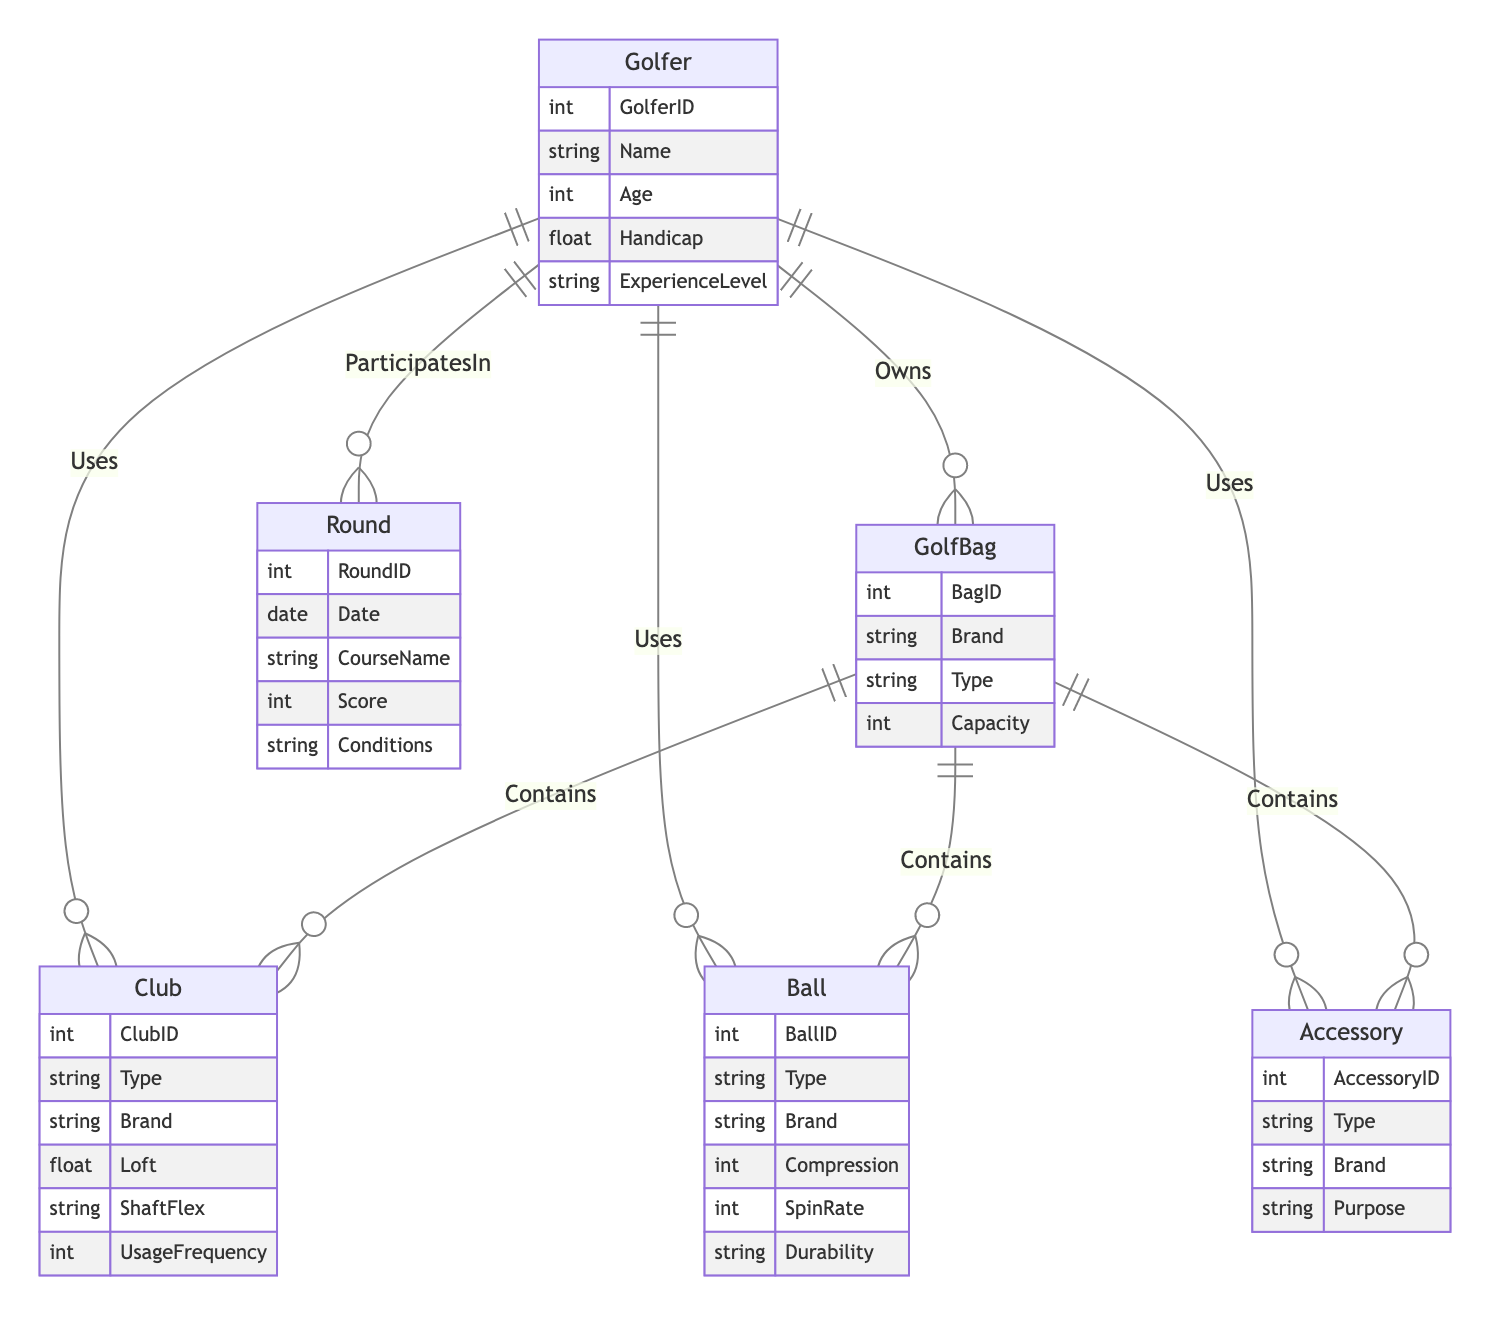What entities are in the diagram? The diagram includes five entities: Golfer, Club, Ball, Accessory, and GolfBag, along with one entity for Round.
Answer: Golfer, Club, Ball, Accessory, GolfBag, Round How many relationships are there in the diagram? The diagram has eight relationships connecting the entities, indicating how they interact.
Answer: 8 What is the relationship between Golfer and Round? The diagram shows that a Golfer participates in a Round, illustrating the connection between players and the games they play.
Answer: ParticipatesIn What type of relationship exists between GolfBag and Club? The relationship between GolfBag and Club is that the GolfBag contains Clubs, showing that equipment is stored within the bag.
Answer: Contains What attributes does the Ball entity have? The attributes for the Ball entity included in the diagram are BallID, Type, Brand, Compression, SpinRate, and Durability, providing key characteristics for golf balls.
Answer: BallID, Type, Brand, Compression, SpinRate, Durability How is UsageFrequency associated with Clubs and Balls? The UsageFrequency attribute on the relationships indicates how often a Golfer uses Clubs and Balls, highlighting the importance of these items in a golfer’s game.
Answer: UsageFrequency Which entity is owned by Golfer? The diagram indicates that a GolfBag is owned by a Golfer, showing that golfers possess bags to carry their equipment.
Answer: GolfBag What attributes link Golfer to Accessory? The relationship shows that Golfer uses Accessory, and the linked attribute is UsageFrequency, which indicates how often accessories are utilized.
Answer: UsageFrequency What does the Club entity type specify? The Club entity includes attributes such as Type, Brand, Loft, and ShaftFlex, detailing the characteristics of different golf clubs.
Answer: Type, Brand, Loft, ShaftFlex Which entity is related to the Conditions during the Round? The Round entity has an attribute called Conditions that reflects the playing environment in which the golfs take place.
Answer: Conditions 